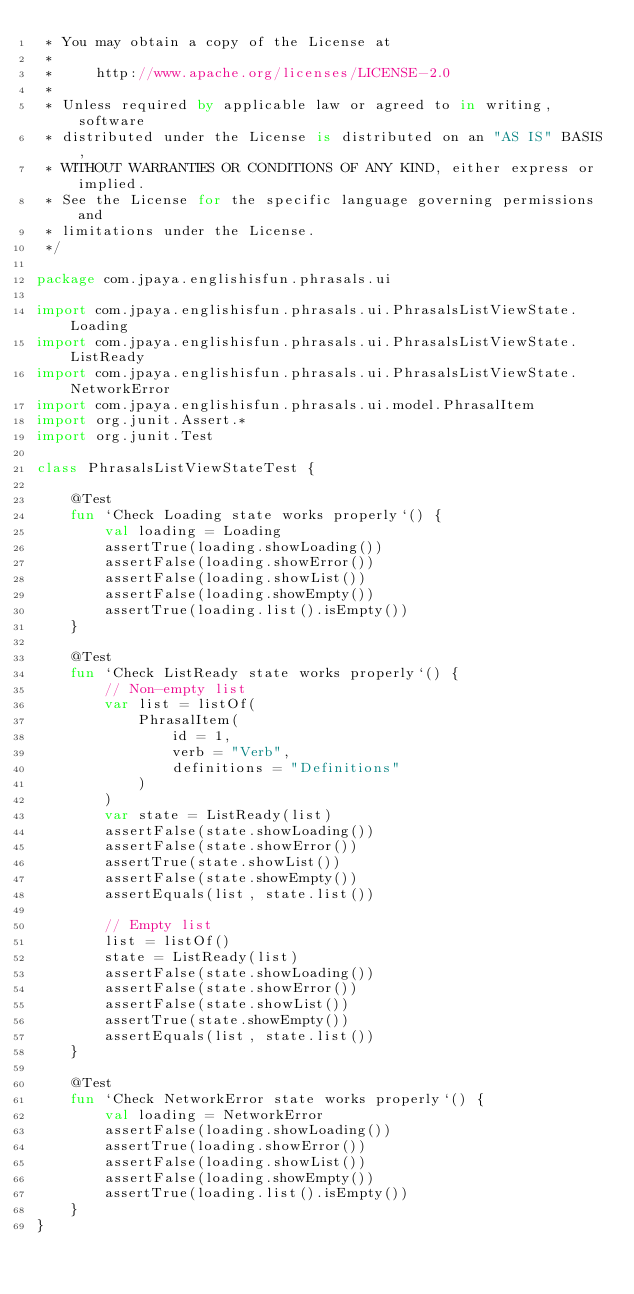<code> <loc_0><loc_0><loc_500><loc_500><_Kotlin_> * You may obtain a copy of the License at
 *
 *     http://www.apache.org/licenses/LICENSE-2.0
 *
 * Unless required by applicable law or agreed to in writing, software
 * distributed under the License is distributed on an "AS IS" BASIS,
 * WITHOUT WARRANTIES OR CONDITIONS OF ANY KIND, either express or implied.
 * See the License for the specific language governing permissions and
 * limitations under the License.
 */

package com.jpaya.englishisfun.phrasals.ui

import com.jpaya.englishisfun.phrasals.ui.PhrasalsListViewState.Loading
import com.jpaya.englishisfun.phrasals.ui.PhrasalsListViewState.ListReady
import com.jpaya.englishisfun.phrasals.ui.PhrasalsListViewState.NetworkError
import com.jpaya.englishisfun.phrasals.ui.model.PhrasalItem
import org.junit.Assert.*
import org.junit.Test

class PhrasalsListViewStateTest {

    @Test
    fun `Check Loading state works properly`() {
        val loading = Loading
        assertTrue(loading.showLoading())
        assertFalse(loading.showError())
        assertFalse(loading.showList())
        assertFalse(loading.showEmpty())
        assertTrue(loading.list().isEmpty())
    }

    @Test
    fun `Check ListReady state works properly`() {
        // Non-empty list
        var list = listOf(
            PhrasalItem(
                id = 1,
                verb = "Verb",
                definitions = "Definitions"
            )
        )
        var state = ListReady(list)
        assertFalse(state.showLoading())
        assertFalse(state.showError())
        assertTrue(state.showList())
        assertFalse(state.showEmpty())
        assertEquals(list, state.list())

        // Empty list
        list = listOf()
        state = ListReady(list)
        assertFalse(state.showLoading())
        assertFalse(state.showError())
        assertFalse(state.showList())
        assertTrue(state.showEmpty())
        assertEquals(list, state.list())
    }

    @Test
    fun `Check NetworkError state works properly`() {
        val loading = NetworkError
        assertFalse(loading.showLoading())
        assertTrue(loading.showError())
        assertFalse(loading.showList())
        assertFalse(loading.showEmpty())
        assertTrue(loading.list().isEmpty())
    }
}
</code> 